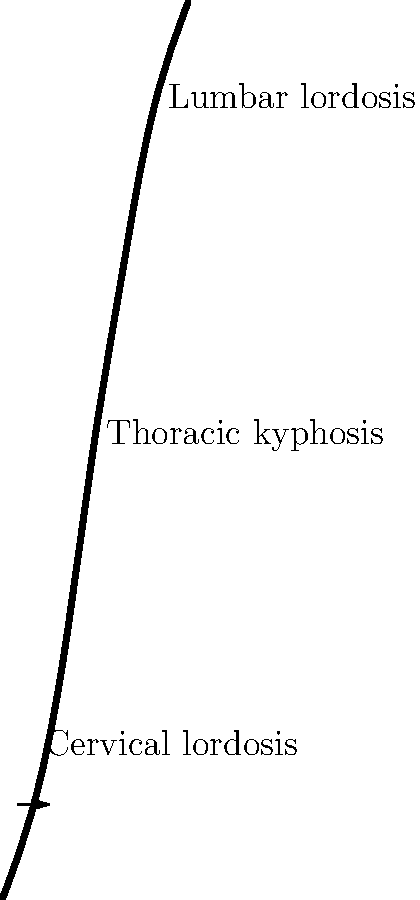In the context of spinal biomechanics, how does the exaggeration of lumbar lordosis potentially impact an individual's posture and risk of lower back pain? Consider the legal implications for workplace ergonomics and potential liability issues. To answer this question, let's break down the biomechanical and legal aspects step-by-step:

1. Lumbar lordosis is the inward curve of the lower back, as shown in the sagittal view of the spine.

2. Exaggeration of lumbar lordosis means an increase in this inward curve beyond normal limits.

3. Biomechanical effects of exaggerated lumbar lordosis:
   a) Increased compressive forces on the posterior elements of the spine
   b) Altered distribution of weight-bearing through the vertebral bodies
   c) Potential strain on ligaments and muscles supporting the lower back

4. Postural impact:
   a) Anterior pelvic tilt
   b) Protruding abdomen
   c) Increased stress on the lower back muscles

5. Risk of lower back pain:
   a) Higher compressive forces can lead to facet joint irritation
   b) Increased risk of muscle fatigue and strain
   c) Potential for intervertebral disc degeneration over time

6. Legal implications for workplace ergonomics:
   a) Employers have a duty of care to provide a safe working environment
   b) This includes ergonomically designed workstations to minimize the risk of musculoskeletal disorders
   c) Failure to address ergonomic issues could result in liability for work-related injuries

7. Potential liability issues:
   a) Workers' compensation claims for lower back injuries
   b) Personal injury lawsuits if negligence in workplace design can be proven
   c) Regulatory fines for non-compliance with occupational health and safety standards

8. Preventive measures from a legal standpoint:
   a) Implementing ergonomic assessments of workstations
   b) Providing adjustable furniture to accommodate different body types
   c) Offering employee training on proper posture and ergonomics
   d) Regular review and updating of workplace safety policies

In conclusion, exaggerated lumbar lordosis can significantly impact posture and increase the risk of lower back pain. From a legal perspective, this creates potential liability for employers who fail to address ergonomic concerns in the workplace.
Answer: Exaggerated lumbar lordosis increases lower back strain and pain risk, potentially leading to employer liability for inadequate workplace ergonomics. 